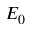Convert formula to latex. <formula><loc_0><loc_0><loc_500><loc_500>E _ { 0 }</formula> 